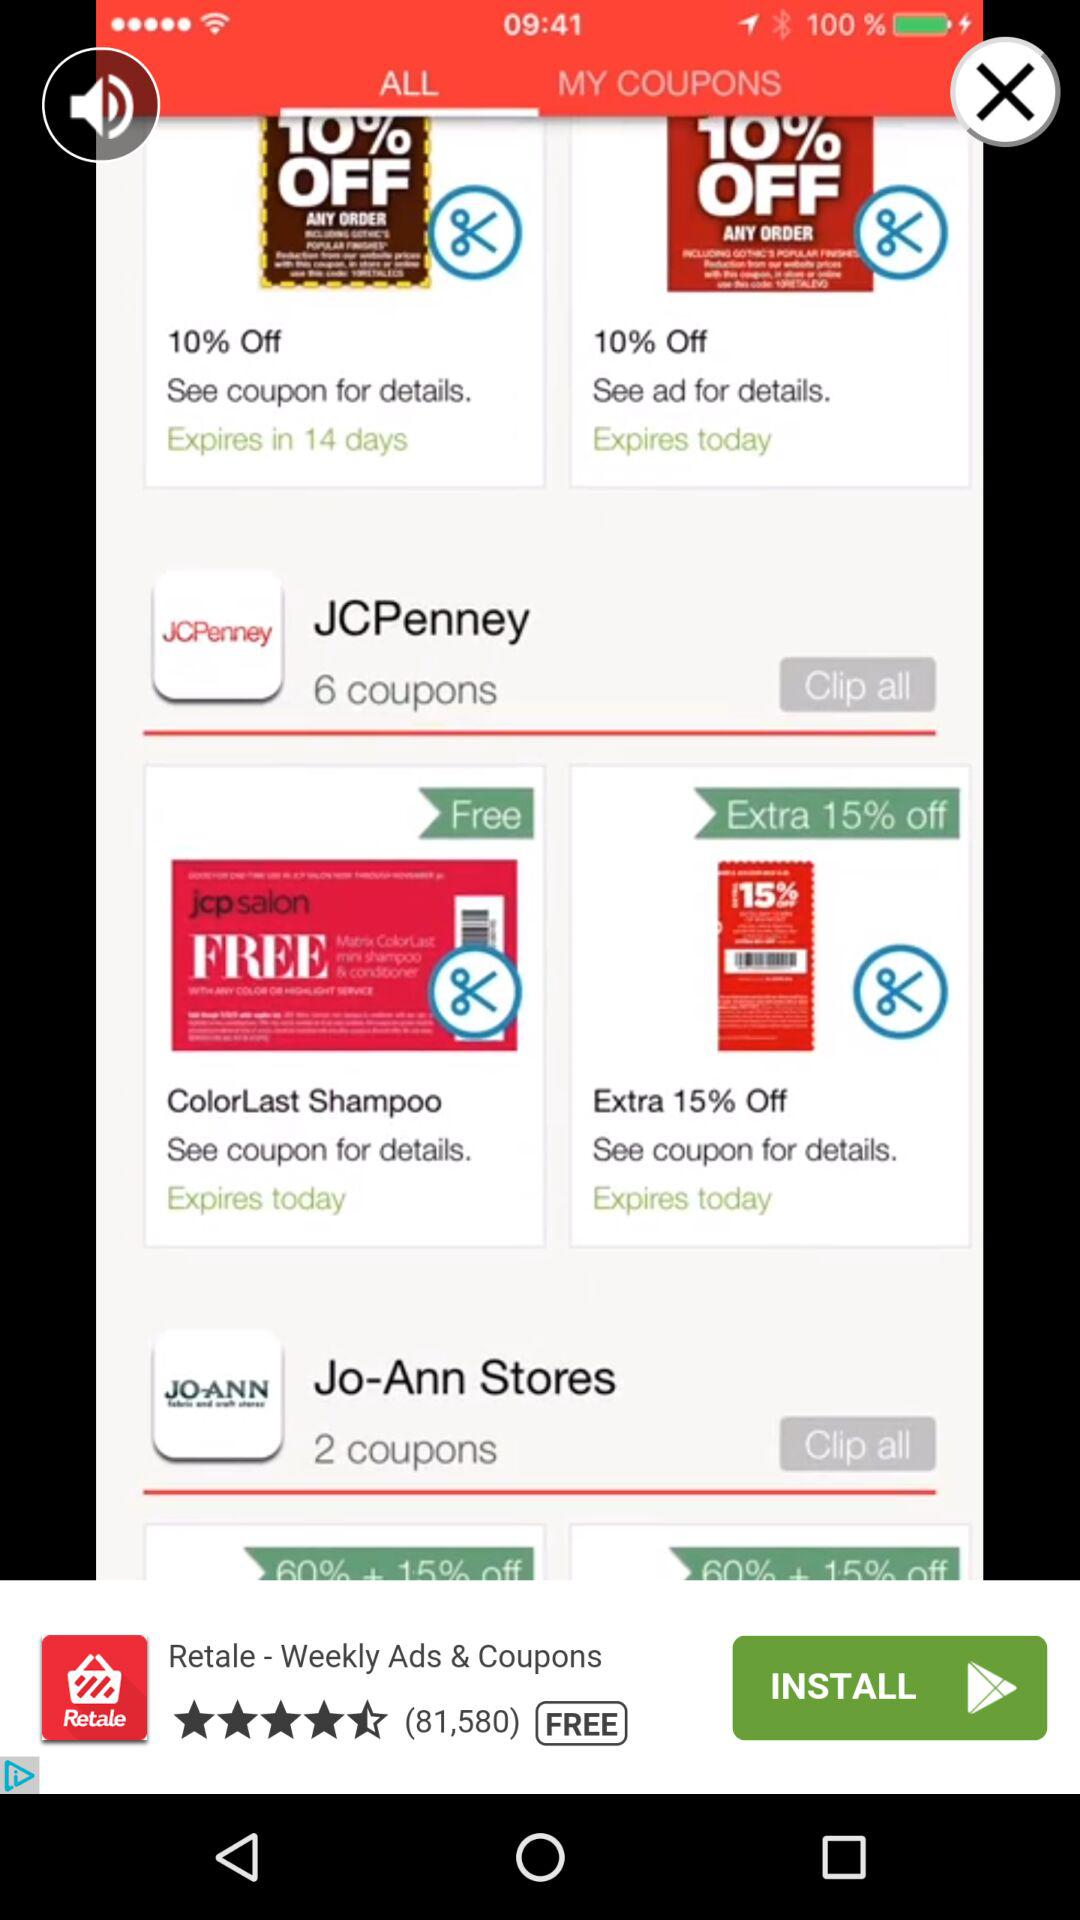How many more coupons are there for JCPenney than Jo-Ann Stores?
Answer the question using a single word or phrase. 4 